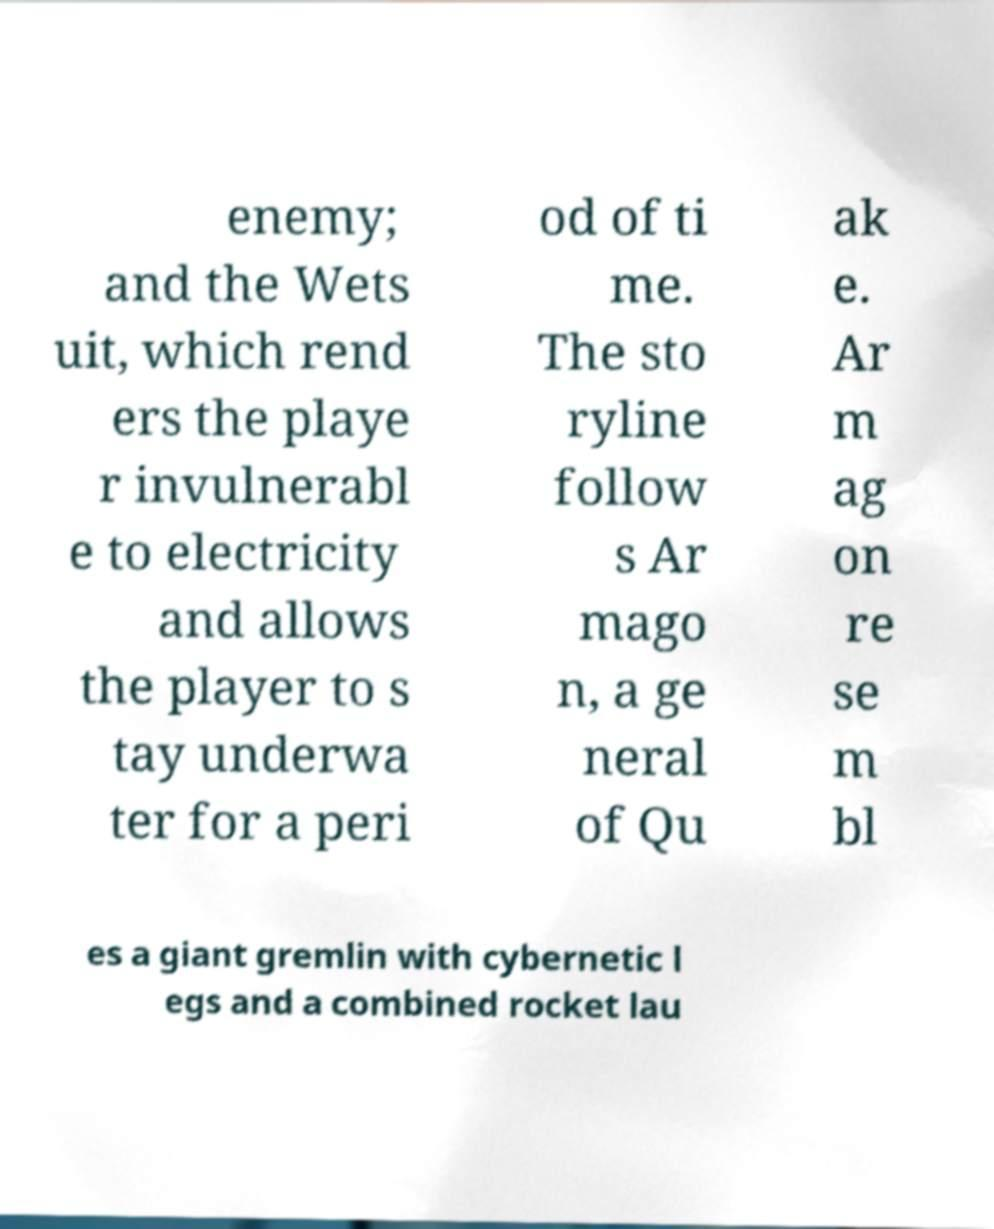Can you accurately transcribe the text from the provided image for me? enemy; and the Wets uit, which rend ers the playe r invulnerabl e to electricity and allows the player to s tay underwa ter for a peri od of ti me. The sto ryline follow s Ar mago n, a ge neral of Qu ak e. Ar m ag on re se m bl es a giant gremlin with cybernetic l egs and a combined rocket lau 